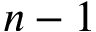<formula> <loc_0><loc_0><loc_500><loc_500>n - 1</formula> 